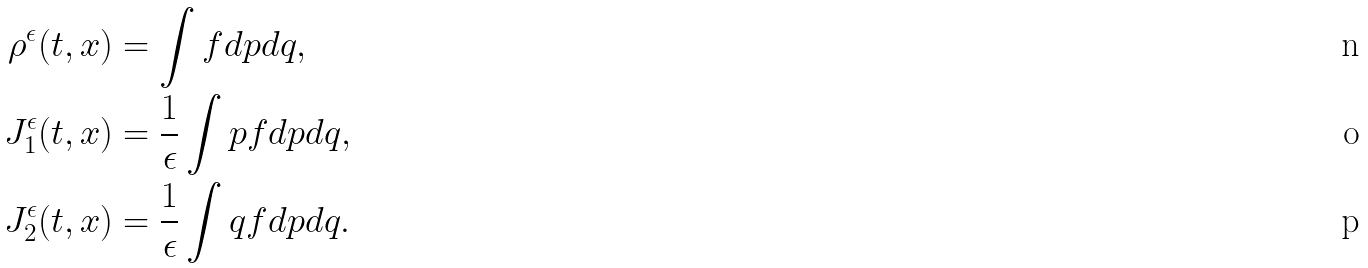<formula> <loc_0><loc_0><loc_500><loc_500>\rho ^ { \epsilon } ( t , x ) & = \int f d p d q , \\ J _ { 1 } ^ { \epsilon } ( t , x ) & = \frac { 1 } { \epsilon } \int p f d p d q , \\ J _ { 2 } ^ { \epsilon } ( t , x ) & = \frac { 1 } { \epsilon } \int q f d p d q .</formula> 